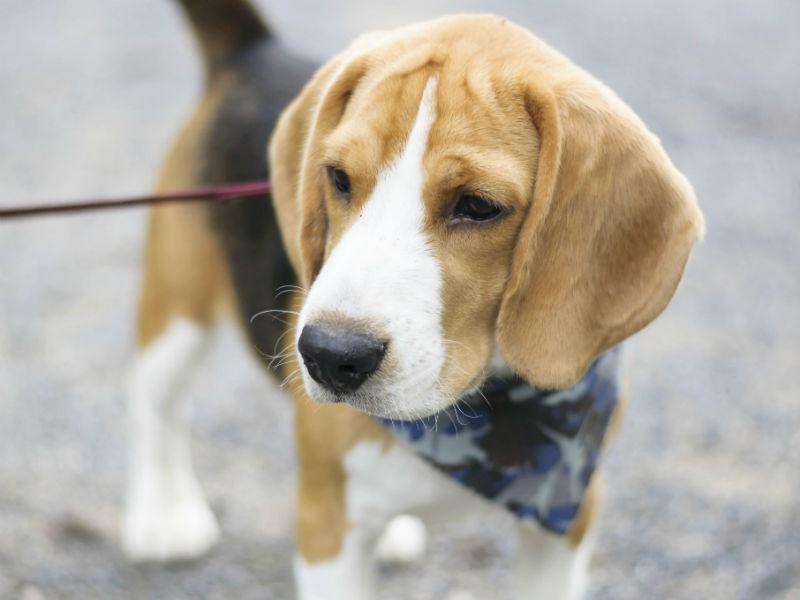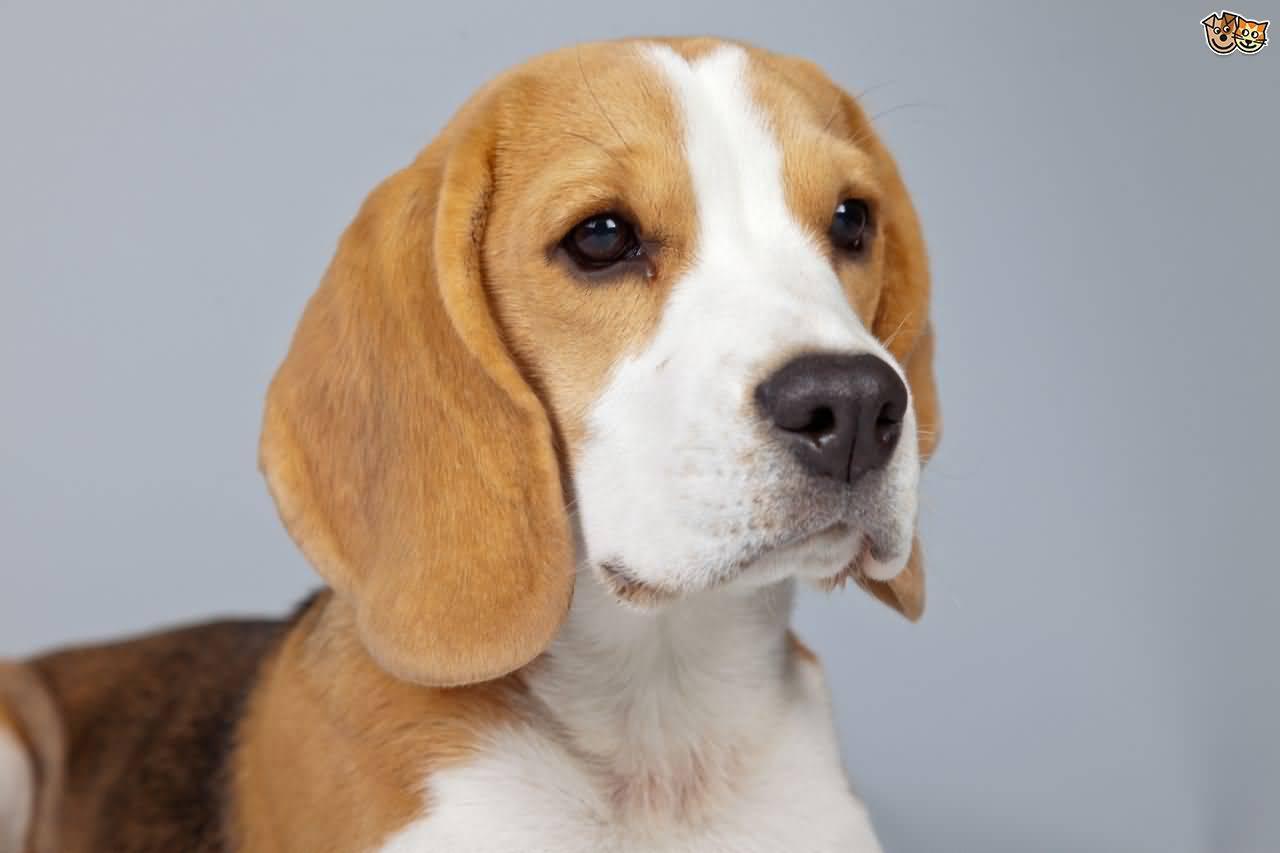The first image is the image on the left, the second image is the image on the right. Analyze the images presented: Is the assertion "One image shows a dog with a tail curled inward, standing on all fours with its body in profile and wearing a collar." valid? Answer yes or no. No. The first image is the image on the left, the second image is the image on the right. Evaluate the accuracy of this statement regarding the images: "One dog is on a leash.". Is it true? Answer yes or no. Yes. 